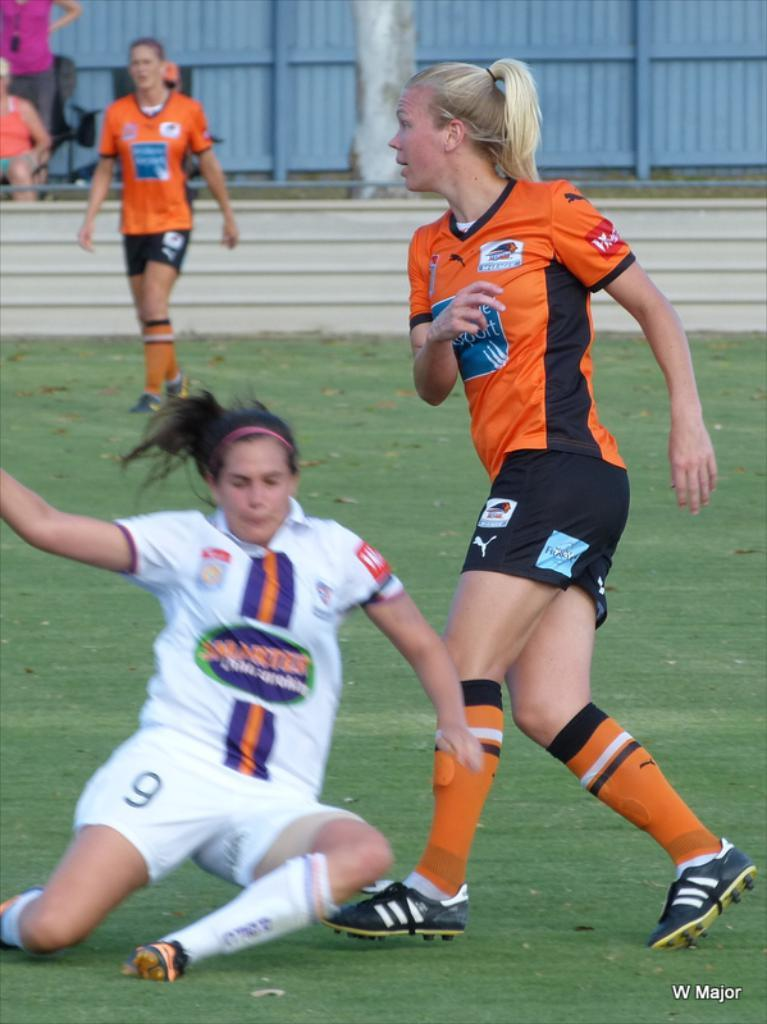<image>
Offer a succinct explanation of the picture presented. A female soccer player no 9 is sliding in front of a player from the opposing team. 